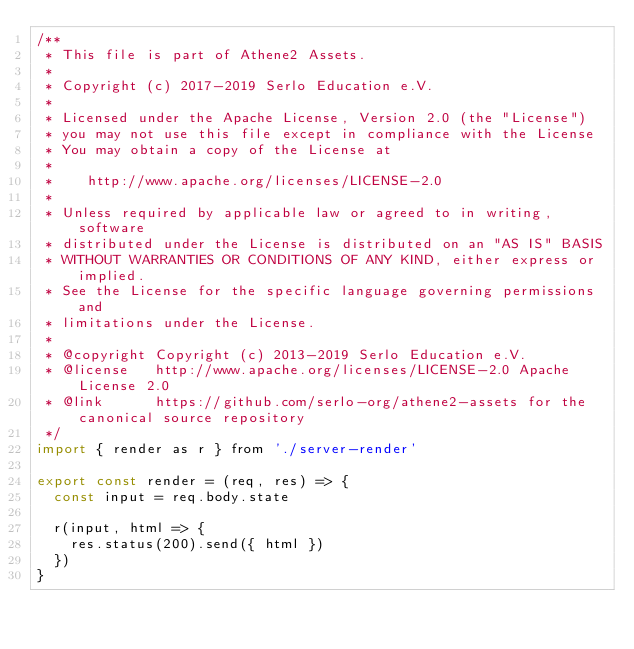<code> <loc_0><loc_0><loc_500><loc_500><_JavaScript_>/**
 * This file is part of Athene2 Assets.
 *
 * Copyright (c) 2017-2019 Serlo Education e.V.
 *
 * Licensed under the Apache License, Version 2.0 (the "License")
 * you may not use this file except in compliance with the License
 * You may obtain a copy of the License at
 *
 *    http://www.apache.org/licenses/LICENSE-2.0
 *
 * Unless required by applicable law or agreed to in writing, software
 * distributed under the License is distributed on an "AS IS" BASIS
 * WITHOUT WARRANTIES OR CONDITIONS OF ANY KIND, either express or implied.
 * See the License for the specific language governing permissions and
 * limitations under the License.
 *
 * @copyright Copyright (c) 2013-2019 Serlo Education e.V.
 * @license   http://www.apache.org/licenses/LICENSE-2.0 Apache License 2.0
 * @link      https://github.com/serlo-org/athene2-assets for the canonical source repository
 */
import { render as r } from './server-render'

export const render = (req, res) => {
  const input = req.body.state

  r(input, html => {
    res.status(200).send({ html })
  })
}
</code> 